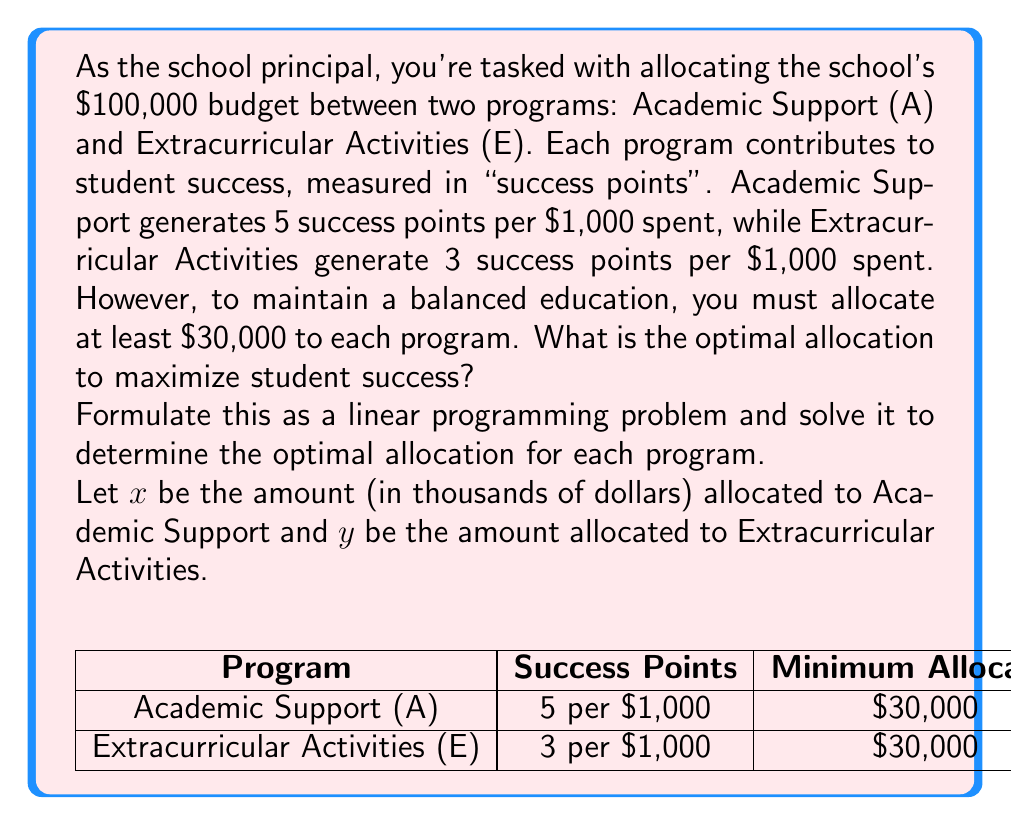What is the answer to this math problem? To solve this linear programming problem, we'll follow these steps:

1) Formulate the objective function:
   Maximize $z = 5x + 3y$ (total success points)

2) Identify the constraints:
   $x + y \leq 100$ (total budget constraint)
   $x \geq 30$ (minimum for Academic Support)
   $y \geq 30$ (minimum for Extracurricular Activities)
   $x, y \geq 0$ (non-negativity constraints)

3) Graph the feasible region:
   [asy]
   import geometry;
   
   size(200);
   
   pair A = (30,70);
   pair B = (70,30);
   pair C = (30,30);
   
   draw((0,100)--(100,0), dashed);
   draw((30,0)--(30,100), dashed);
   draw((0,30)--(100,30), dashed);
   
   filldraw(A--B--C--cycle, lightgray, black);
   
   dot("A(30,70)", A, N);
   dot("B(70,30)", B, SE);
   dot("C(30,30)", C, SW);
   
   label("$x + y = 100$", (50,50), NW);
   label("$x = 30$", (30,50), E);
   label("$y = 30$", (50,30), N);
   
   xaxis("$x$", 0, 100, Arrow);
   yaxis("$y$", 0, 100, Arrow);
   [/asy]

4) Evaluate the objective function at each corner point:
   At A(30,70): $z = 5(30) + 3(70) = 360$
   At B(70,30): $z = 5(70) + 3(30) = 440$
   At C(30,30): $z = 5(30) + 3(30) = 240$

5) The maximum value occurs at point B(70,30), which represents:
   $70,000 for Academic Support
   $30,000 for Extracurricular Activities
Answer: Optimal allocation: $70,000 for Academic Support, $30,000 for Extracurricular Activities 